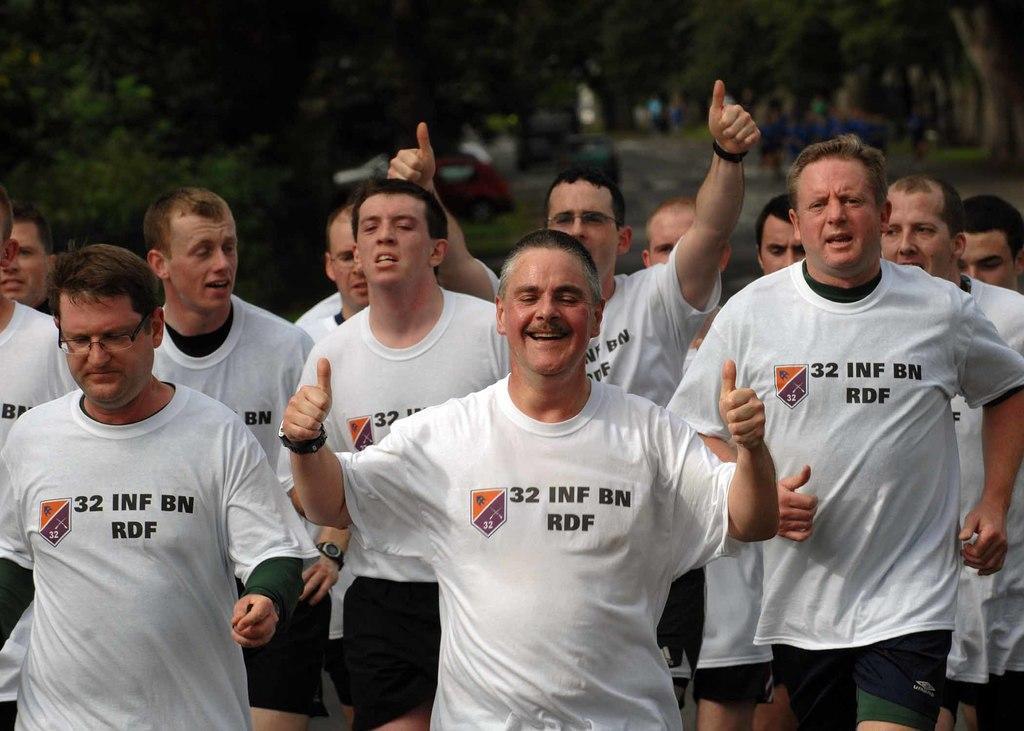Please provide a concise description of this image. In this image, I can see a group of people standing. In the background, there are trees and vehicles on the road. 